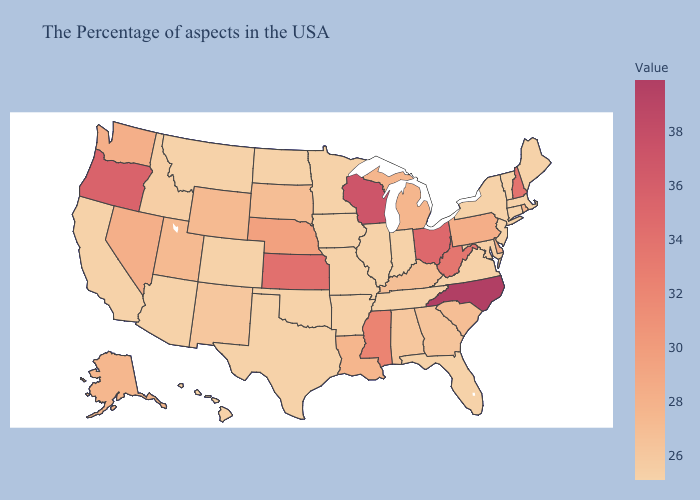Which states have the lowest value in the USA?
Concise answer only. Maine, Massachusetts, Vermont, Connecticut, New York, New Jersey, Virginia, Florida, Indiana, Tennessee, Illinois, Missouri, Arkansas, Minnesota, Iowa, Oklahoma, Texas, North Dakota, Colorado, Montana, Arizona, California, Hawaii. Does the map have missing data?
Short answer required. No. Does Texas have the highest value in the USA?
Concise answer only. No. Does Vermont have the highest value in the Northeast?
Write a very short answer. No. Is the legend a continuous bar?
Answer briefly. Yes. Among the states that border New Hampshire , which have the highest value?
Answer briefly. Maine, Massachusetts, Vermont. Among the states that border New York , does Vermont have the lowest value?
Give a very brief answer. Yes. 